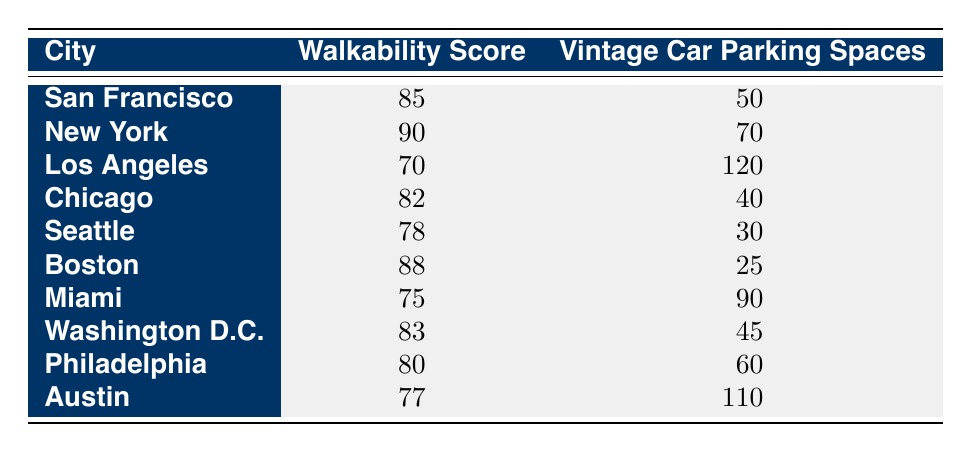What is the walkability score of Boston? The table indicates that Boston has a walkability score of 88.
Answer: 88 Which city has the highest vintage car parking spaces? By comparing the vintage car parking spaces column, Los Angeles has the highest at 120 spaces.
Answer: 120 What is the average walkability score for the cities listed? To find the average walkability score, we sum all the scores: (85 + 90 + 70 + 82 + 78 + 88 + 75 + 83 + 80 + 77) = 825. There are 10 cities, so the average is 825/10 = 82.5.
Answer: 82.5 Is it true that New York has more vintage car parking spaces than San Francisco? Yes, New York has 70 vintage car parking spaces while San Francisco has only 50 spaces.
Answer: Yes Which city has a walkability score lower than 80 and how many vintage car parking spaces does it have? Los Angeles, Miami, and Austin all have walkability scores lower than 80. They have 120, 90, and 110 vintage car parking spaces respectively.
Answer: Los Angeles: 120, Miami: 90, Austin: 110 How many more vintage car parking spaces does Miami have compared to Boston? Miami has 90 vintage car parking spaces, while Boston has 25. The difference is 90 - 25 = 65 spaces more in Miami.
Answer: 65 Are there any cities with a walkability score over 80 that have fewer than 50 vintage car parking spaces? Yes, Chicago has a walkability score of 82 and just 40 vintage car parking spaces.
Answer: Yes What is the combined walkability score of Seattle and Philadelphia? The walkability score for Seattle is 78, and for Philadelphia, it is 80. Combined, they total 78 + 80 = 158.
Answer: 158 In how many cities does the vintage car parking spaces exceed 100? By reviewing the data, Los Angeles has 120 and Austin has 110, totaling 2 cities where vintage car parking spaces exceed 100.
Answer: 2 